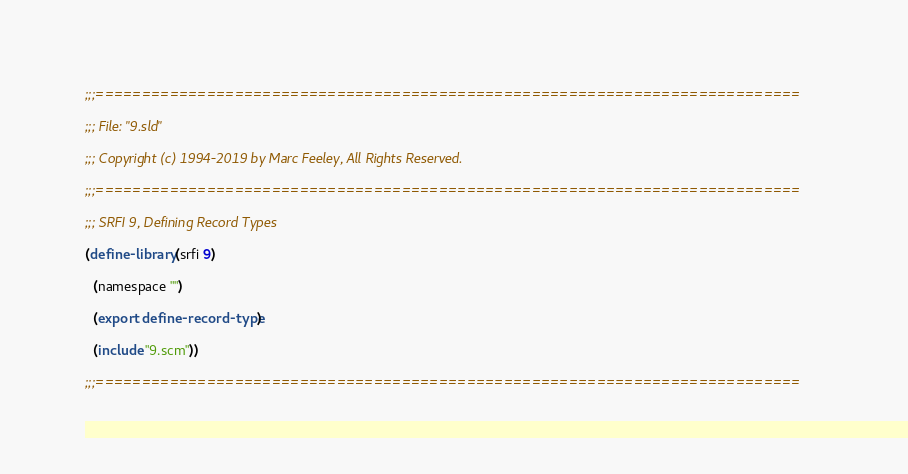<code> <loc_0><loc_0><loc_500><loc_500><_Scheme_>;;;============================================================================

;;; File: "9.sld"

;;; Copyright (c) 1994-2019 by Marc Feeley, All Rights Reserved.

;;;============================================================================

;;; SRFI 9, Defining Record Types

(define-library (srfi 9)

  (namespace "")

  (export define-record-type)

  (include "9.scm"))

;;;============================================================================
</code> 